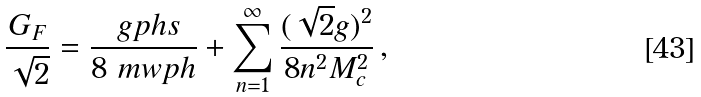<formula> <loc_0><loc_0><loc_500><loc_500>\frac { G _ { F } } { \sqrt { 2 } } = \frac { \ g p h s } { 8 \ m w p h } + \sum ^ { \infty } _ { n = 1 } \frac { ( \sqrt { 2 } g ) ^ { 2 } } { 8 n ^ { 2 } M _ { c } ^ { 2 } } \, ,</formula> 